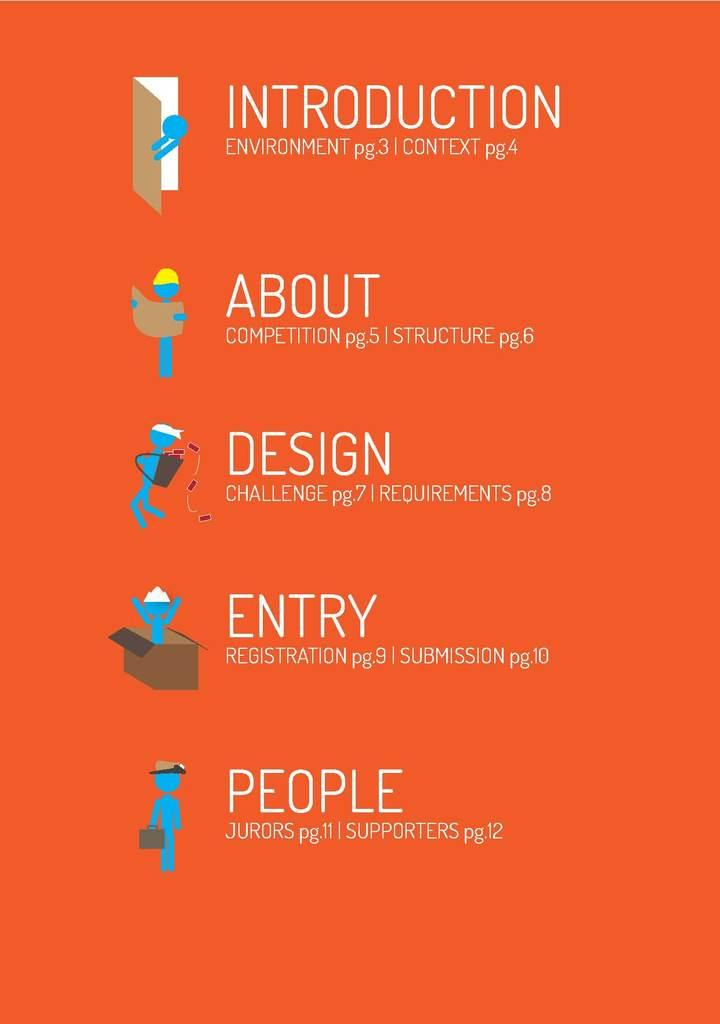<image>
Write a terse but informative summary of the picture. A red instructional poster that has the words Introduction, About, Design, Entry, and People written on it. 